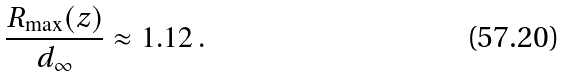Convert formula to latex. <formula><loc_0><loc_0><loc_500><loc_500>\frac { R _ { \max } ( z ) } { d _ { \infty } } \approx 1 . 1 2 \, .</formula> 